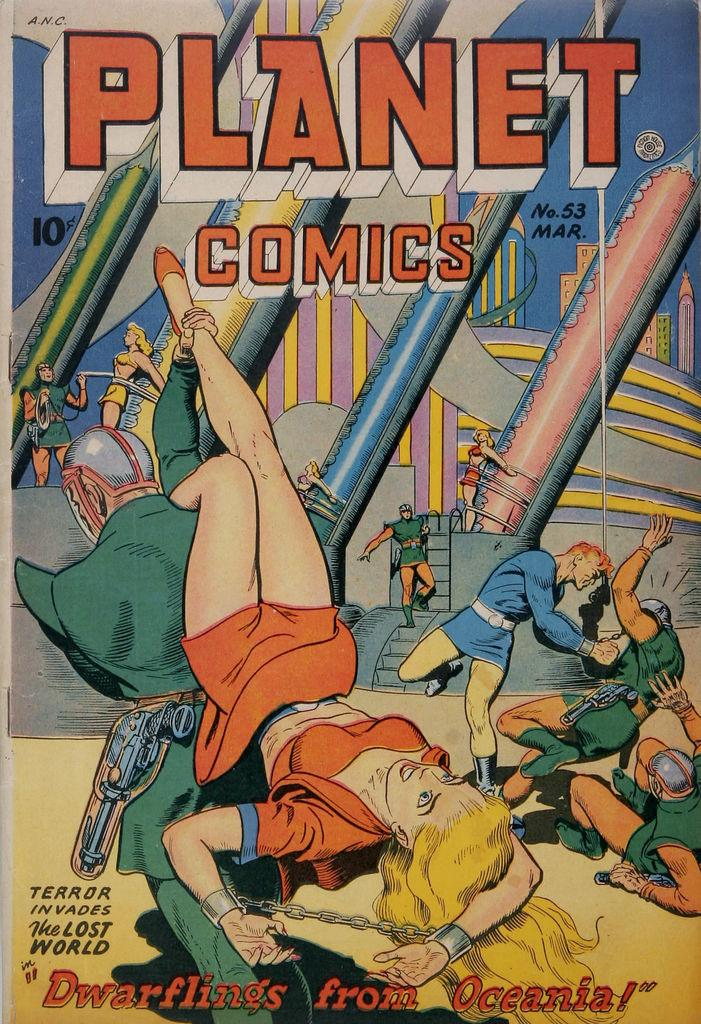<image>
Give a short and clear explanation of the subsequent image. A Planet Comics comic book shows a woman in an orange outfit. 